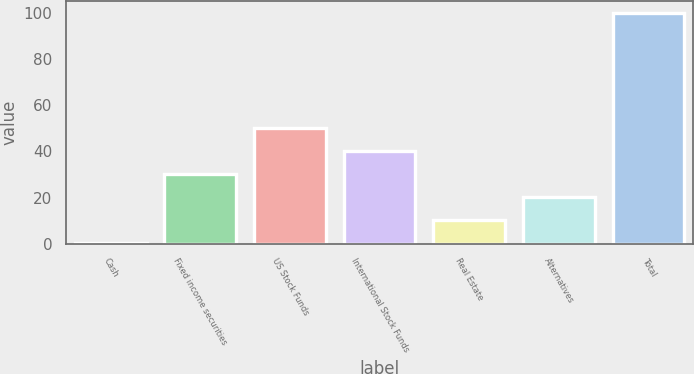Convert chart to OTSL. <chart><loc_0><loc_0><loc_500><loc_500><bar_chart><fcel>Cash<fcel>Fixed income securities<fcel>US Stock Funds<fcel>International Stock Funds<fcel>Real Estate<fcel>Alternatives<fcel>Total<nl><fcel>0.3<fcel>30.21<fcel>50.15<fcel>40.18<fcel>10.27<fcel>20.24<fcel>100<nl></chart> 